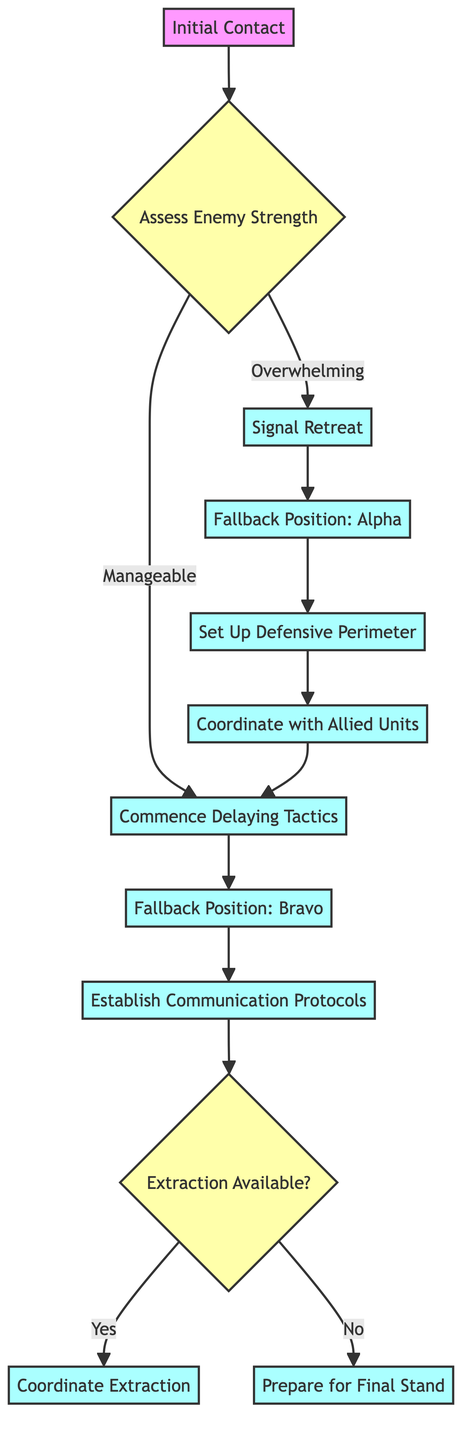What is the first action taken after making initial contact? The first action after "Initial Contact" is "Assess Enemy Strength", which determines the next steps based on the enemy's capacity.
Answer: Assess Enemy Strength How many fallback positions are specified in the diagram? There are two fallback positions mentioned in the diagram: "Fallback Position: Alpha" and "Fallback Position: Bravo".
Answer: Two What is the next step if the enemy strength is assessed as manageable? If the enemy strength is manageable, the next step is to "Commence Delaying Tactics".
Answer: Commence Delaying Tactics Which action follows the signaling of retreat? After signaling the retreat, the action that follows is to move to "Fallback Position: Alpha".
Answer: Fallback Position: Alpha What contributes to the decision tree in the diagram? The decision tree is influenced by the assessment of enemy strength at the decision point, leading to either signaling a retreat or managing the enemy forces.
Answer: Assess Enemy Strength What happens if extraction is available according to the flow chart? If extraction is available, the process will lead to "Coordinate Extraction", enabling the safe withdrawal of units.
Answer: Coordinate Extraction Which action is taken after establishing communication protocols? After establishing communication protocols, the team reaches a decision point regarding the availability of extraction.
Answer: Extraction Available? What is the purpose of the "Set Up Defensive Perimeter" action? The purpose of setting up a defensive perimeter is to secure the fallback position and delay enemy advancement.
Answer: Secure the fallback position What is the final action taken if extraction is not available? If extraction is not available, the final action is to "Prepare for Final Stand", where units ready themselves for potential confrontation.
Answer: Prepare for Final Stand 